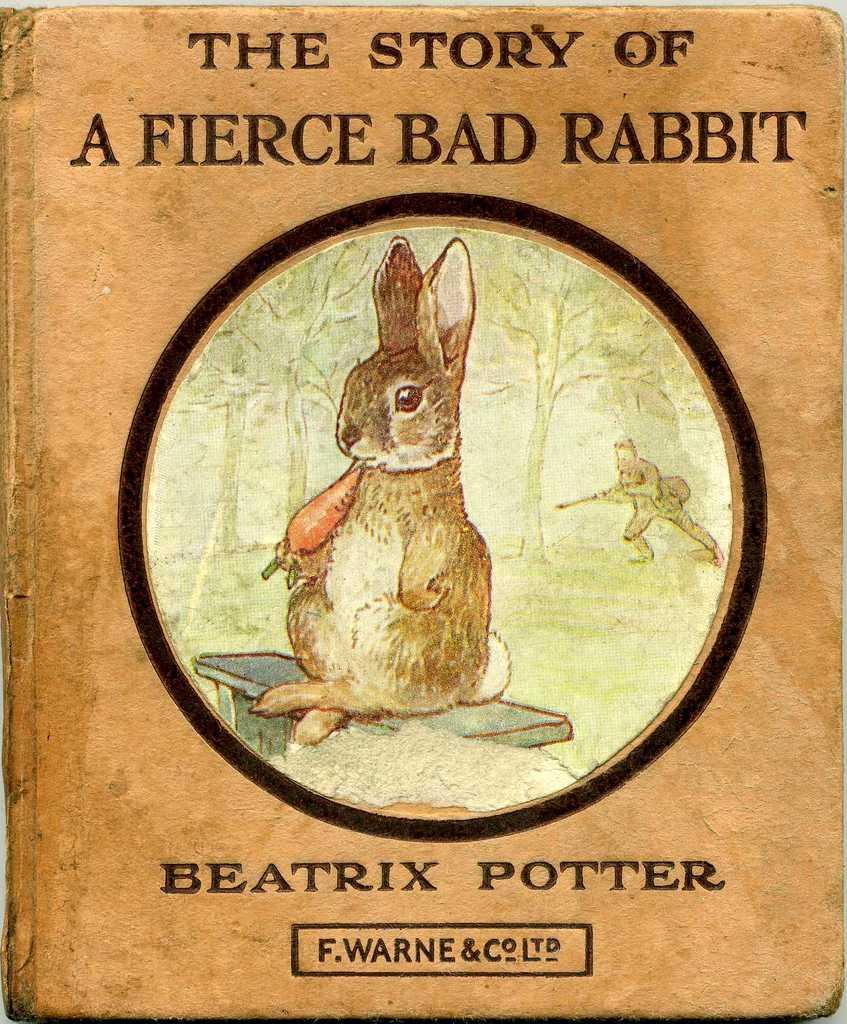Could you give a brief overview of what you see in this image? In this image we can see cover page of a book which has rabbit which is holding carrot and in the background of the image there are some trees and a hunter holding gun in his hands. 